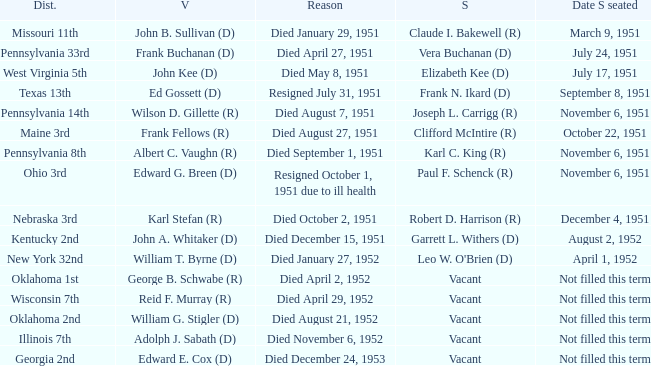Who was the successor for the Kentucky 2nd district? Garrett L. Withers (D). 